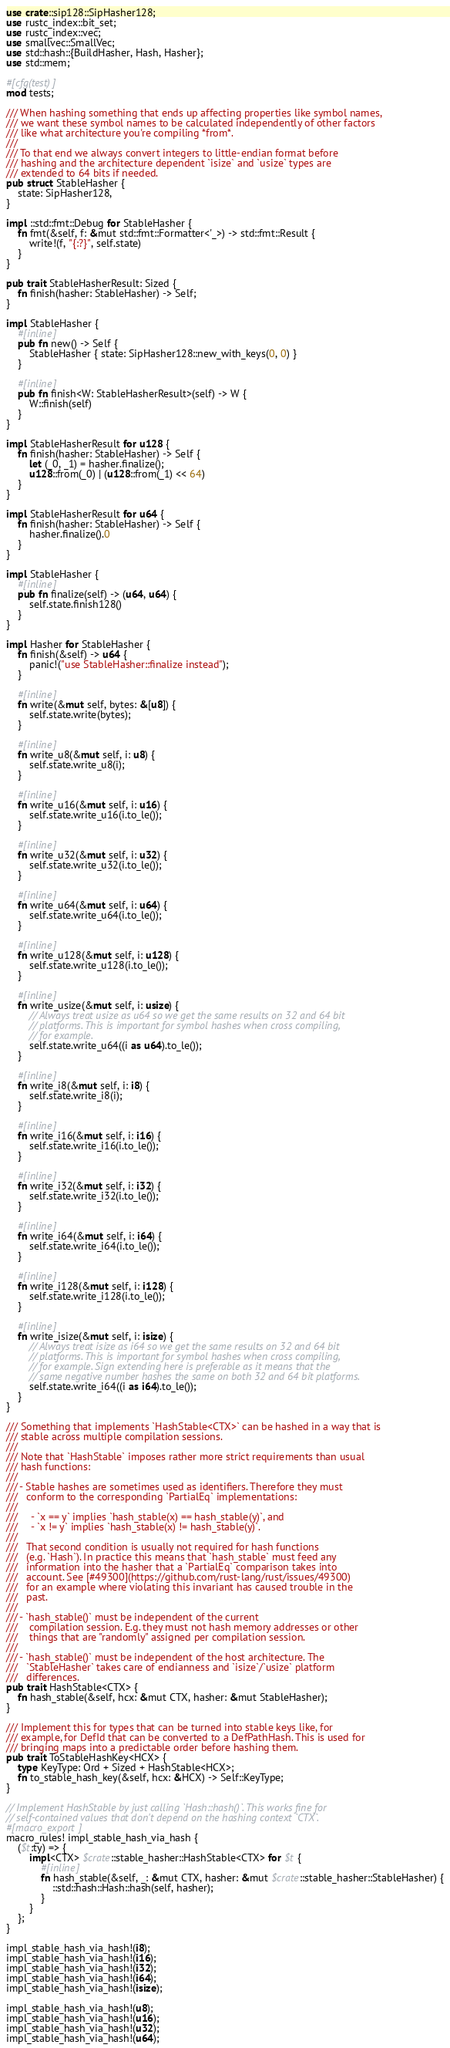<code> <loc_0><loc_0><loc_500><loc_500><_Rust_>use crate::sip128::SipHasher128;
use rustc_index::bit_set;
use rustc_index::vec;
use smallvec::SmallVec;
use std::hash::{BuildHasher, Hash, Hasher};
use std::mem;

#[cfg(test)]
mod tests;

/// When hashing something that ends up affecting properties like symbol names,
/// we want these symbol names to be calculated independently of other factors
/// like what architecture you're compiling *from*.
///
/// To that end we always convert integers to little-endian format before
/// hashing and the architecture dependent `isize` and `usize` types are
/// extended to 64 bits if needed.
pub struct StableHasher {
    state: SipHasher128,
}

impl ::std::fmt::Debug for StableHasher {
    fn fmt(&self, f: &mut std::fmt::Formatter<'_>) -> std::fmt::Result {
        write!(f, "{:?}", self.state)
    }
}

pub trait StableHasherResult: Sized {
    fn finish(hasher: StableHasher) -> Self;
}

impl StableHasher {
    #[inline]
    pub fn new() -> Self {
        StableHasher { state: SipHasher128::new_with_keys(0, 0) }
    }

    #[inline]
    pub fn finish<W: StableHasherResult>(self) -> W {
        W::finish(self)
    }
}

impl StableHasherResult for u128 {
    fn finish(hasher: StableHasher) -> Self {
        let (_0, _1) = hasher.finalize();
        u128::from(_0) | (u128::from(_1) << 64)
    }
}

impl StableHasherResult for u64 {
    fn finish(hasher: StableHasher) -> Self {
        hasher.finalize().0
    }
}

impl StableHasher {
    #[inline]
    pub fn finalize(self) -> (u64, u64) {
        self.state.finish128()
    }
}

impl Hasher for StableHasher {
    fn finish(&self) -> u64 {
        panic!("use StableHasher::finalize instead");
    }

    #[inline]
    fn write(&mut self, bytes: &[u8]) {
        self.state.write(bytes);
    }

    #[inline]
    fn write_u8(&mut self, i: u8) {
        self.state.write_u8(i);
    }

    #[inline]
    fn write_u16(&mut self, i: u16) {
        self.state.write_u16(i.to_le());
    }

    #[inline]
    fn write_u32(&mut self, i: u32) {
        self.state.write_u32(i.to_le());
    }

    #[inline]
    fn write_u64(&mut self, i: u64) {
        self.state.write_u64(i.to_le());
    }

    #[inline]
    fn write_u128(&mut self, i: u128) {
        self.state.write_u128(i.to_le());
    }

    #[inline]
    fn write_usize(&mut self, i: usize) {
        // Always treat usize as u64 so we get the same results on 32 and 64 bit
        // platforms. This is important for symbol hashes when cross compiling,
        // for example.
        self.state.write_u64((i as u64).to_le());
    }

    #[inline]
    fn write_i8(&mut self, i: i8) {
        self.state.write_i8(i);
    }

    #[inline]
    fn write_i16(&mut self, i: i16) {
        self.state.write_i16(i.to_le());
    }

    #[inline]
    fn write_i32(&mut self, i: i32) {
        self.state.write_i32(i.to_le());
    }

    #[inline]
    fn write_i64(&mut self, i: i64) {
        self.state.write_i64(i.to_le());
    }

    #[inline]
    fn write_i128(&mut self, i: i128) {
        self.state.write_i128(i.to_le());
    }

    #[inline]
    fn write_isize(&mut self, i: isize) {
        // Always treat isize as i64 so we get the same results on 32 and 64 bit
        // platforms. This is important for symbol hashes when cross compiling,
        // for example. Sign extending here is preferable as it means that the
        // same negative number hashes the same on both 32 and 64 bit platforms.
        self.state.write_i64((i as i64).to_le());
    }
}

/// Something that implements `HashStable<CTX>` can be hashed in a way that is
/// stable across multiple compilation sessions.
///
/// Note that `HashStable` imposes rather more strict requirements than usual
/// hash functions:
///
/// - Stable hashes are sometimes used as identifiers. Therefore they must
///   conform to the corresponding `PartialEq` implementations:
///
///     - `x == y` implies `hash_stable(x) == hash_stable(y)`, and
///     - `x != y` implies `hash_stable(x) != hash_stable(y)`.
///
///   That second condition is usually not required for hash functions
///   (e.g. `Hash`). In practice this means that `hash_stable` must feed any
///   information into the hasher that a `PartialEq` comparison takes into
///   account. See [#49300](https://github.com/rust-lang/rust/issues/49300)
///   for an example where violating this invariant has caused trouble in the
///   past.
///
/// - `hash_stable()` must be independent of the current
///    compilation session. E.g. they must not hash memory addresses or other
///    things that are "randomly" assigned per compilation session.
///
/// - `hash_stable()` must be independent of the host architecture. The
///   `StableHasher` takes care of endianness and `isize`/`usize` platform
///   differences.
pub trait HashStable<CTX> {
    fn hash_stable(&self, hcx: &mut CTX, hasher: &mut StableHasher);
}

/// Implement this for types that can be turned into stable keys like, for
/// example, for DefId that can be converted to a DefPathHash. This is used for
/// bringing maps into a predictable order before hashing them.
pub trait ToStableHashKey<HCX> {
    type KeyType: Ord + Sized + HashStable<HCX>;
    fn to_stable_hash_key(&self, hcx: &HCX) -> Self::KeyType;
}

// Implement HashStable by just calling `Hash::hash()`. This works fine for
// self-contained values that don't depend on the hashing context `CTX`.
#[macro_export]
macro_rules! impl_stable_hash_via_hash {
    ($t:ty) => {
        impl<CTX> $crate::stable_hasher::HashStable<CTX> for $t {
            #[inline]
            fn hash_stable(&self, _: &mut CTX, hasher: &mut $crate::stable_hasher::StableHasher) {
                ::std::hash::Hash::hash(self, hasher);
            }
        }
    };
}

impl_stable_hash_via_hash!(i8);
impl_stable_hash_via_hash!(i16);
impl_stable_hash_via_hash!(i32);
impl_stable_hash_via_hash!(i64);
impl_stable_hash_via_hash!(isize);

impl_stable_hash_via_hash!(u8);
impl_stable_hash_via_hash!(u16);
impl_stable_hash_via_hash!(u32);
impl_stable_hash_via_hash!(u64);</code> 